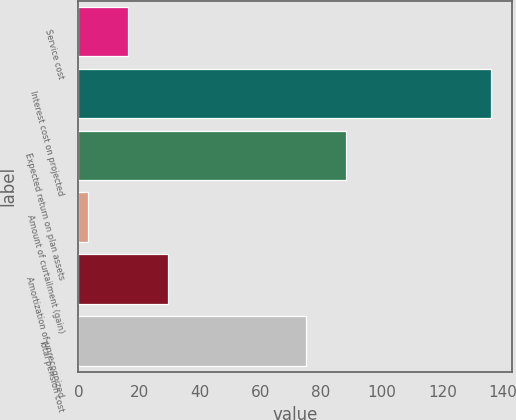<chart> <loc_0><loc_0><loc_500><loc_500><bar_chart><fcel>Service cost<fcel>Interest cost on projected<fcel>Expected return on plan assets<fcel>Amount of curtailment (gain)<fcel>Amortization of unrecognized<fcel>Total pension cost<nl><fcel>16.3<fcel>136<fcel>88.3<fcel>3<fcel>29.6<fcel>75<nl></chart> 